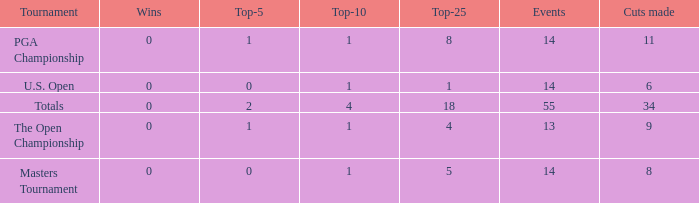What is the average top-5 when the cuts made is more than 34? None. Write the full table. {'header': ['Tournament', 'Wins', 'Top-5', 'Top-10', 'Top-25', 'Events', 'Cuts made'], 'rows': [['PGA Championship', '0', '1', '1', '8', '14', '11'], ['U.S. Open', '0', '0', '1', '1', '14', '6'], ['Totals', '0', '2', '4', '18', '55', '34'], ['The Open Championship', '0', '1', '1', '4', '13', '9'], ['Masters Tournament', '0', '0', '1', '5', '14', '8']]} 